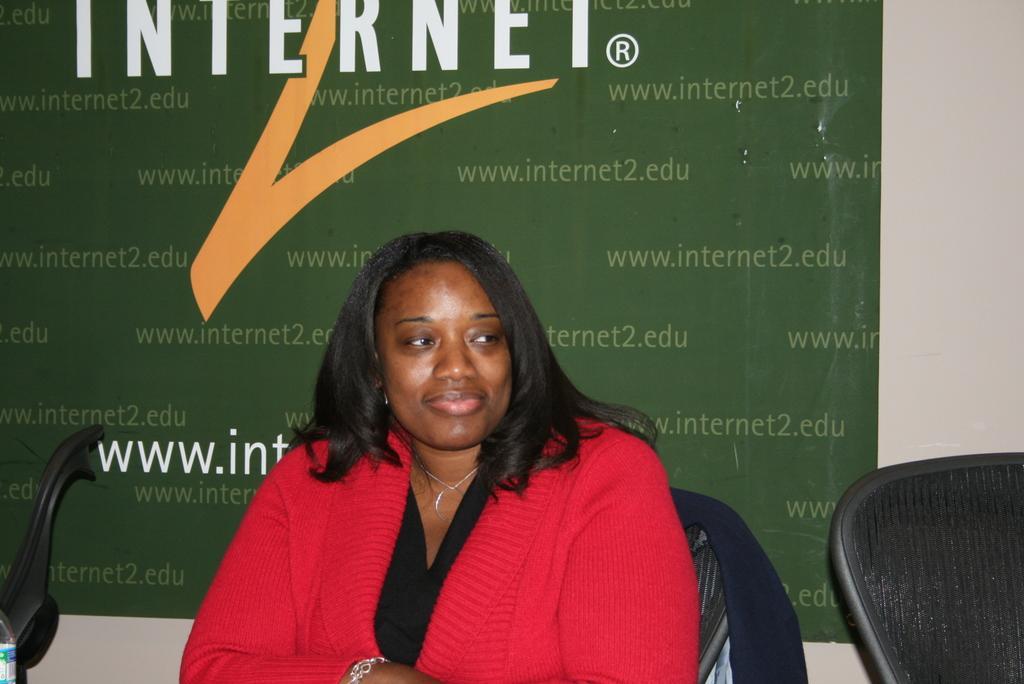In one or two sentences, can you explain what this image depicts? In this picture I can see a woman seated in the chair and I can see chairs on the both sides and I can see a banner with some text. 